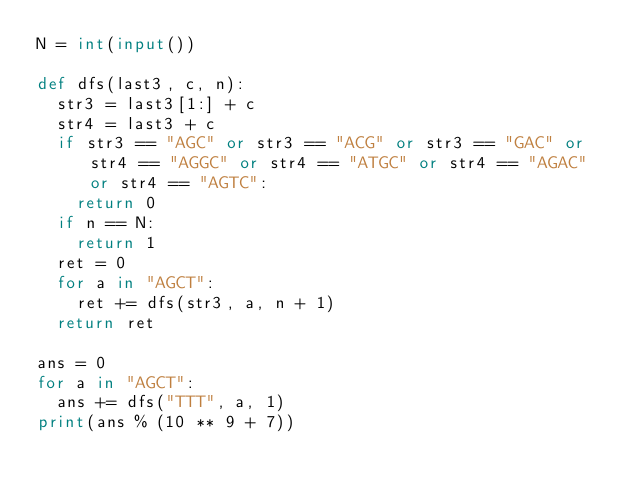<code> <loc_0><loc_0><loc_500><loc_500><_Python_>N = int(input())

def dfs(last3, c, n):
  str3 = last3[1:] + c
  str4 = last3 + c
  if str3 == "AGC" or str3 == "ACG" or str3 == "GAC" or str4 == "AGGC" or str4 == "ATGC" or str4 == "AGAC" or str4 == "AGTC":
    return 0
  if n == N:
    return 1
  ret = 0
  for a in "AGCT":
    ret += dfs(str3, a, n + 1)
  return ret

ans = 0
for a in "AGCT":
  ans += dfs("TTT", a, 1)
print(ans % (10 ** 9 + 7))</code> 